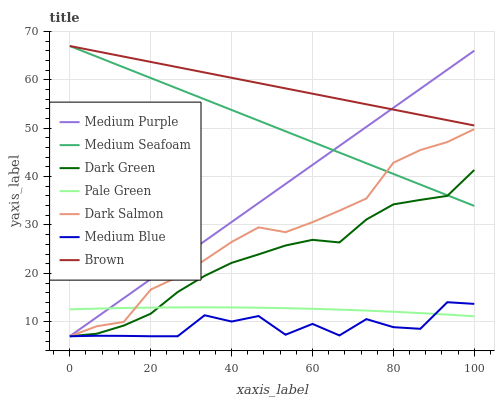Does Medium Blue have the minimum area under the curve?
Answer yes or no. Yes. Does Brown have the maximum area under the curve?
Answer yes or no. Yes. Does Dark Salmon have the minimum area under the curve?
Answer yes or no. No. Does Dark Salmon have the maximum area under the curve?
Answer yes or no. No. Is Medium Purple the smoothest?
Answer yes or no. Yes. Is Medium Blue the roughest?
Answer yes or no. Yes. Is Dark Salmon the smoothest?
Answer yes or no. No. Is Dark Salmon the roughest?
Answer yes or no. No. Does Medium Blue have the lowest value?
Answer yes or no. Yes. Does Pale Green have the lowest value?
Answer yes or no. No. Does Medium Seafoam have the highest value?
Answer yes or no. Yes. Does Medium Blue have the highest value?
Answer yes or no. No. Is Dark Green less than Brown?
Answer yes or no. Yes. Is Medium Seafoam greater than Medium Blue?
Answer yes or no. Yes. Does Dark Green intersect Medium Blue?
Answer yes or no. Yes. Is Dark Green less than Medium Blue?
Answer yes or no. No. Is Dark Green greater than Medium Blue?
Answer yes or no. No. Does Dark Green intersect Brown?
Answer yes or no. No. 